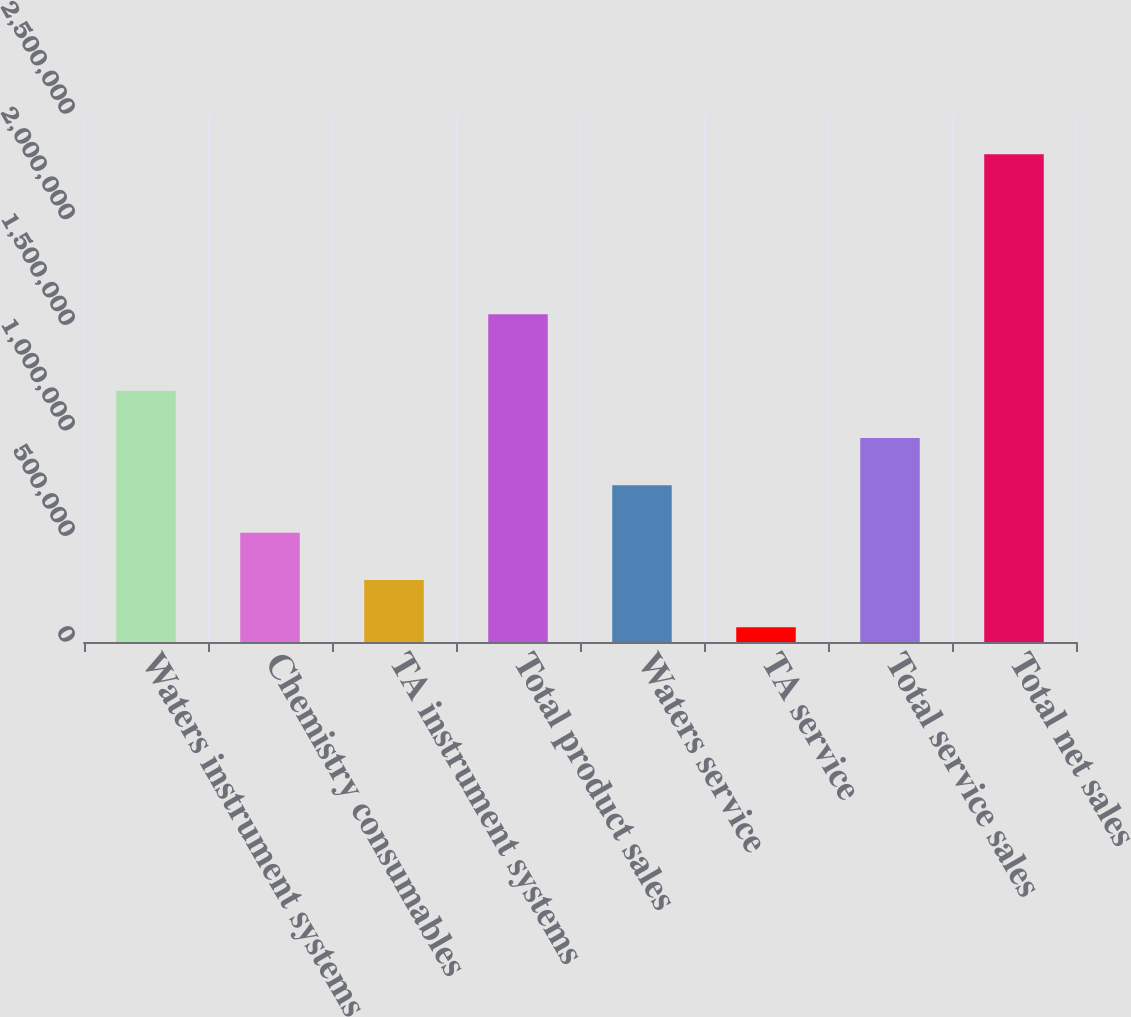Convert chart to OTSL. <chart><loc_0><loc_0><loc_500><loc_500><bar_chart><fcel>Waters instrument systems<fcel>Chemistry consumables<fcel>TA instrument systems<fcel>Total product sales<fcel>Waters service<fcel>TA service<fcel>Total service sales<fcel>Total net sales<nl><fcel>1.18958e+06<fcel>517874<fcel>293974<fcel>1.55235e+06<fcel>741774<fcel>70073<fcel>965675<fcel>2.30908e+06<nl></chart> 